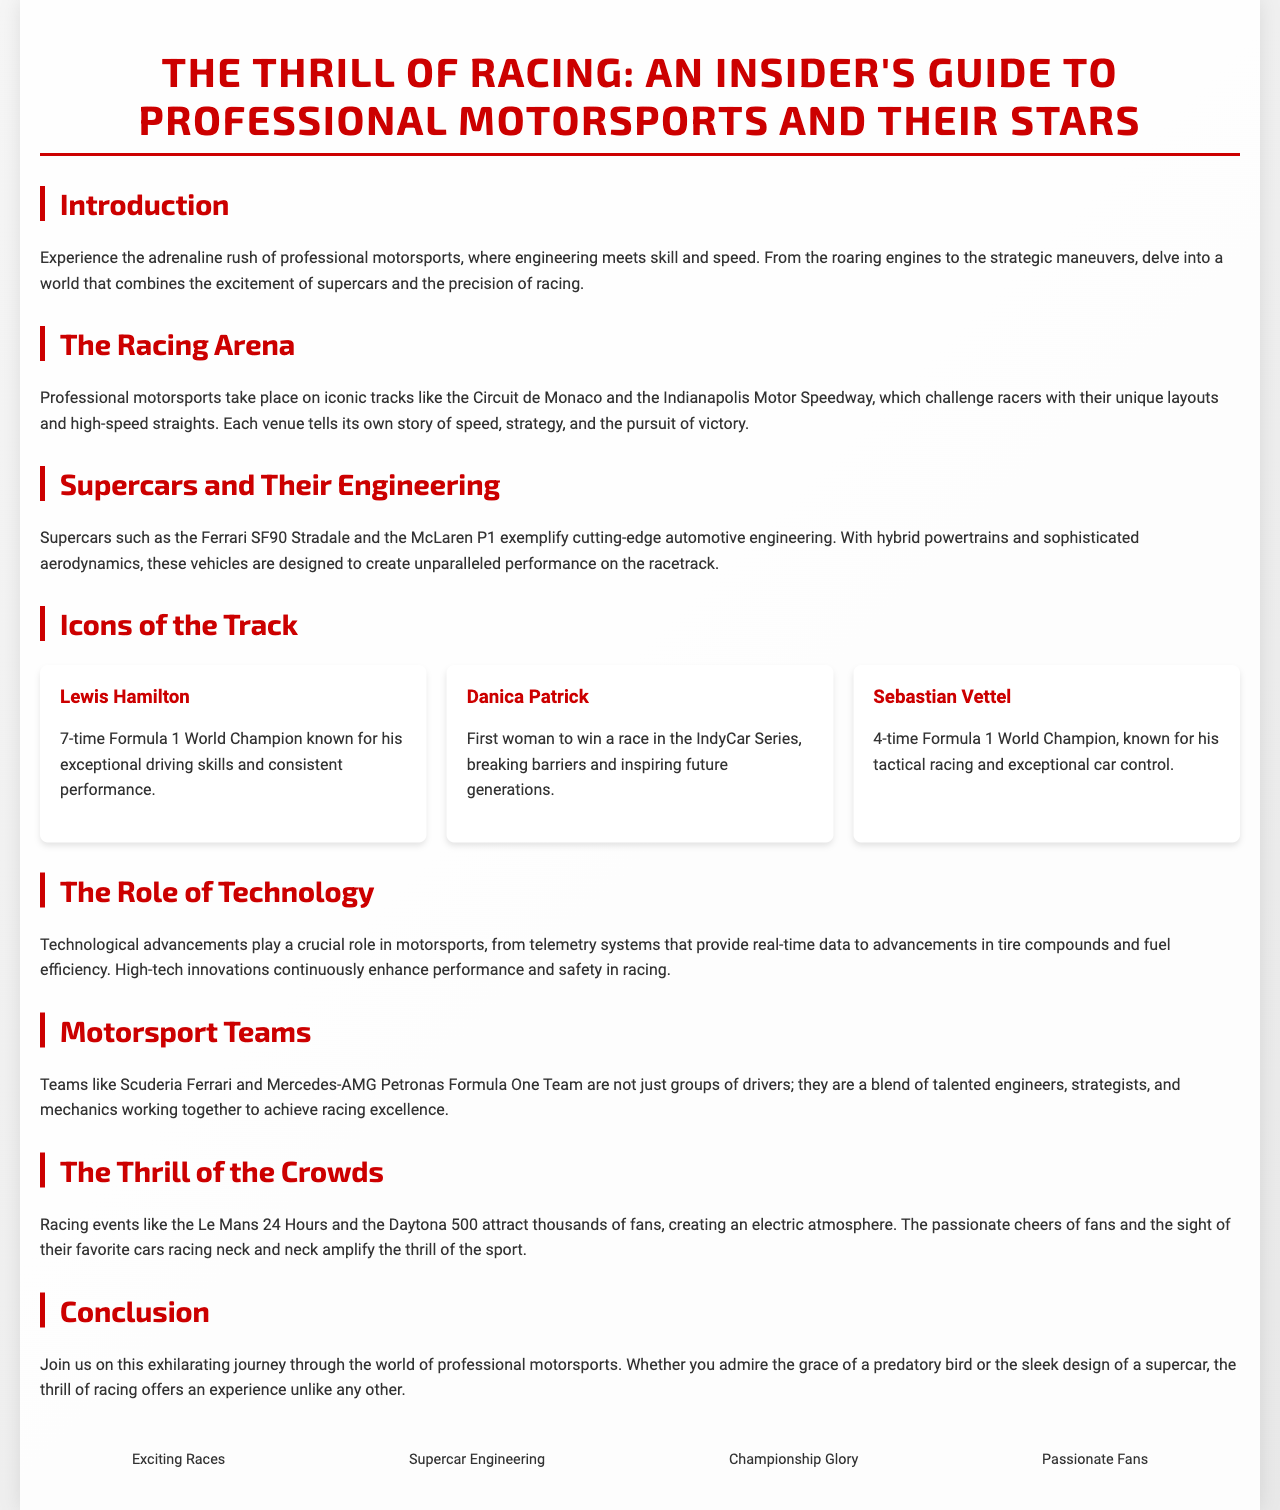What is the main theme of the brochure? The main theme of the brochure centers around the excitement and intricacies of professional motorsports.
Answer: motorsports What is the title of a supercar mentioned in the document? The document lists specific supercars as examples of cutting-edge engineering in professional motorsports.
Answer: Ferrari SF90 Stradale Who is a 7-time Formula 1 World Champion featured in the brochure? The brochure highlights notable racing figures and their accomplishments.
Answer: Lewis Hamilton How many icons of the track are listed in the document? There are sections that showcase notable personalities in racing, categorized as icons of the track.
Answer: three What role do technological advancements play in motorsports according to the document? The document emphasizes the importance of technology in enhancing racing performance and safety.
Answer: crucial Which racing event is mentioned as attracting thousands of fans? The brochure discusses specific racing events that are famous for their large audiences.
Answer: Daytona 500 Who was the first woman to win a race in the IndyCar Series? The document points out inspiring figures in racing history, particularly those who broke barriers.
Answer: Danica Patrick What color is primarily used for headings in the document? The design of the brochure incorporates distinct colors to differentiate sections visually.
Answer: red 